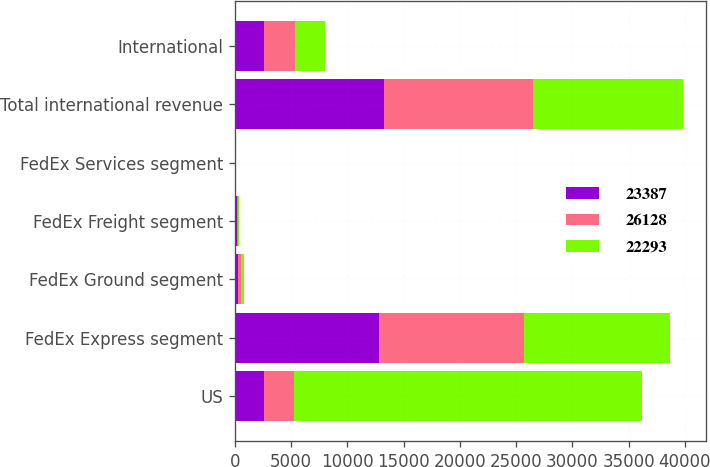Convert chart. <chart><loc_0><loc_0><loc_500><loc_500><stacked_bar_chart><ecel><fcel>US<fcel>FedEx Express segment<fcel>FedEx Ground segment<fcel>FedEx Freight segment<fcel>FedEx Services segment<fcel>Total international revenue<fcel>International<nl><fcel>23387<fcel>2614<fcel>12772<fcel>311<fcel>142<fcel>12<fcel>13237<fcel>2614<nl><fcel>26128<fcel>2614<fcel>12916<fcel>248<fcel>130<fcel>14<fcel>13308<fcel>2729<nl><fcel>22293<fcel>30948<fcel>12959<fcel>234<fcel>112<fcel>34<fcel>13339<fcel>2656<nl></chart> 